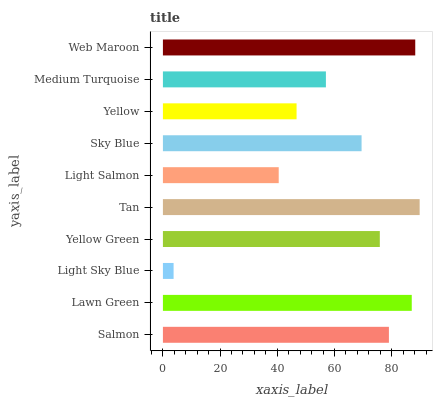Is Light Sky Blue the minimum?
Answer yes or no. Yes. Is Tan the maximum?
Answer yes or no. Yes. Is Lawn Green the minimum?
Answer yes or no. No. Is Lawn Green the maximum?
Answer yes or no. No. Is Lawn Green greater than Salmon?
Answer yes or no. Yes. Is Salmon less than Lawn Green?
Answer yes or no. Yes. Is Salmon greater than Lawn Green?
Answer yes or no. No. Is Lawn Green less than Salmon?
Answer yes or no. No. Is Yellow Green the high median?
Answer yes or no. Yes. Is Sky Blue the low median?
Answer yes or no. Yes. Is Yellow the high median?
Answer yes or no. No. Is Yellow the low median?
Answer yes or no. No. 